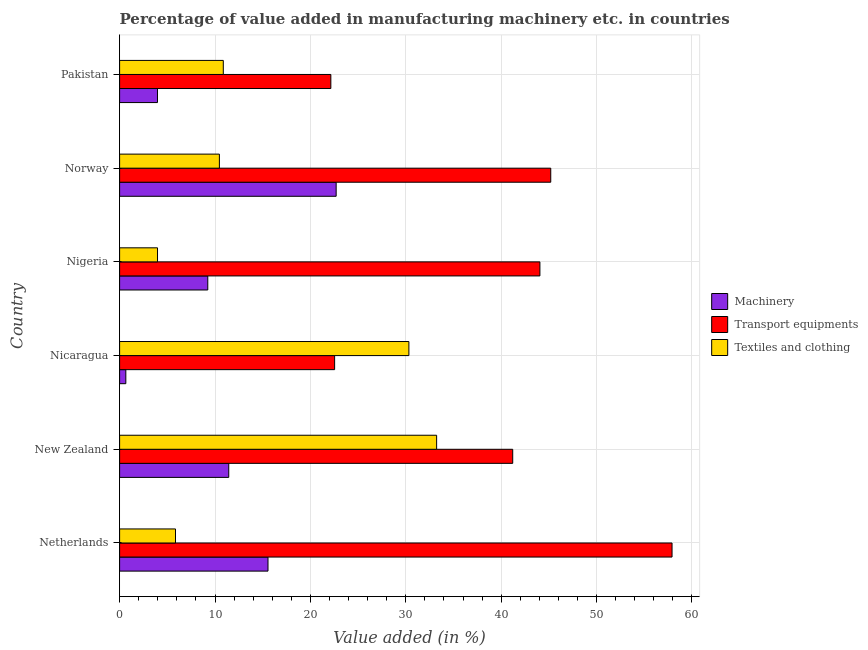How many different coloured bars are there?
Your response must be concise. 3. Are the number of bars per tick equal to the number of legend labels?
Offer a terse response. Yes. How many bars are there on the 3rd tick from the top?
Make the answer very short. 3. What is the label of the 3rd group of bars from the top?
Your answer should be very brief. Nigeria. In how many cases, is the number of bars for a given country not equal to the number of legend labels?
Offer a terse response. 0. What is the value added in manufacturing textile and clothing in Norway?
Keep it short and to the point. 10.46. Across all countries, what is the maximum value added in manufacturing machinery?
Your answer should be very brief. 22.7. Across all countries, what is the minimum value added in manufacturing transport equipments?
Your response must be concise. 22.14. In which country was the value added in manufacturing machinery minimum?
Provide a short and direct response. Nicaragua. What is the total value added in manufacturing textile and clothing in the graph?
Your response must be concise. 94.72. What is the difference between the value added in manufacturing machinery in Nigeria and that in Norway?
Provide a short and direct response. -13.46. What is the difference between the value added in manufacturing transport equipments in Norway and the value added in manufacturing machinery in Nicaragua?
Your answer should be very brief. 44.54. What is the average value added in manufacturing textile and clothing per country?
Keep it short and to the point. 15.79. What is the difference between the value added in manufacturing textile and clothing and value added in manufacturing transport equipments in Nigeria?
Ensure brevity in your answer.  -40.09. What is the ratio of the value added in manufacturing machinery in New Zealand to that in Nigeria?
Ensure brevity in your answer.  1.24. Is the value added in manufacturing machinery in Norway less than that in Pakistan?
Offer a very short reply. No. What is the difference between the highest and the second highest value added in manufacturing transport equipments?
Make the answer very short. 12.71. What is the difference between the highest and the lowest value added in manufacturing transport equipments?
Your response must be concise. 35.77. In how many countries, is the value added in manufacturing transport equipments greater than the average value added in manufacturing transport equipments taken over all countries?
Offer a terse response. 4. What does the 1st bar from the top in Nigeria represents?
Keep it short and to the point. Textiles and clothing. What does the 2nd bar from the bottom in Nigeria represents?
Ensure brevity in your answer.  Transport equipments. How many bars are there?
Offer a terse response. 18. How many countries are there in the graph?
Provide a succinct answer. 6. Are the values on the major ticks of X-axis written in scientific E-notation?
Offer a very short reply. No. Does the graph contain any zero values?
Your answer should be compact. No. Does the graph contain grids?
Your answer should be very brief. Yes. How many legend labels are there?
Your answer should be very brief. 3. How are the legend labels stacked?
Your answer should be compact. Vertical. What is the title of the graph?
Offer a very short reply. Percentage of value added in manufacturing machinery etc. in countries. Does "Taxes on income" appear as one of the legend labels in the graph?
Your response must be concise. No. What is the label or title of the X-axis?
Your response must be concise. Value added (in %). What is the Value added (in %) in Machinery in Netherlands?
Provide a succinct answer. 15.56. What is the Value added (in %) of Transport equipments in Netherlands?
Provide a succinct answer. 57.91. What is the Value added (in %) of Textiles and clothing in Netherlands?
Provide a succinct answer. 5.86. What is the Value added (in %) in Machinery in New Zealand?
Give a very brief answer. 11.44. What is the Value added (in %) of Transport equipments in New Zealand?
Offer a terse response. 41.21. What is the Value added (in %) in Textiles and clothing in New Zealand?
Give a very brief answer. 33.23. What is the Value added (in %) in Machinery in Nicaragua?
Ensure brevity in your answer.  0.65. What is the Value added (in %) of Transport equipments in Nicaragua?
Provide a short and direct response. 22.54. What is the Value added (in %) of Textiles and clothing in Nicaragua?
Provide a succinct answer. 30.33. What is the Value added (in %) in Machinery in Nigeria?
Offer a terse response. 9.24. What is the Value added (in %) in Transport equipments in Nigeria?
Your answer should be very brief. 44.06. What is the Value added (in %) of Textiles and clothing in Nigeria?
Provide a succinct answer. 3.97. What is the Value added (in %) in Machinery in Norway?
Keep it short and to the point. 22.7. What is the Value added (in %) of Transport equipments in Norway?
Offer a terse response. 45.2. What is the Value added (in %) of Textiles and clothing in Norway?
Offer a terse response. 10.46. What is the Value added (in %) in Machinery in Pakistan?
Give a very brief answer. 3.97. What is the Value added (in %) in Transport equipments in Pakistan?
Your response must be concise. 22.14. What is the Value added (in %) of Textiles and clothing in Pakistan?
Your answer should be very brief. 10.87. Across all countries, what is the maximum Value added (in %) of Machinery?
Provide a short and direct response. 22.7. Across all countries, what is the maximum Value added (in %) of Transport equipments?
Your answer should be very brief. 57.91. Across all countries, what is the maximum Value added (in %) of Textiles and clothing?
Make the answer very short. 33.23. Across all countries, what is the minimum Value added (in %) of Machinery?
Offer a terse response. 0.65. Across all countries, what is the minimum Value added (in %) of Transport equipments?
Provide a short and direct response. 22.14. Across all countries, what is the minimum Value added (in %) of Textiles and clothing?
Provide a short and direct response. 3.97. What is the total Value added (in %) in Machinery in the graph?
Ensure brevity in your answer.  63.57. What is the total Value added (in %) of Transport equipments in the graph?
Make the answer very short. 233.06. What is the total Value added (in %) in Textiles and clothing in the graph?
Your answer should be very brief. 94.72. What is the difference between the Value added (in %) of Machinery in Netherlands and that in New Zealand?
Offer a very short reply. 4.11. What is the difference between the Value added (in %) in Transport equipments in Netherlands and that in New Zealand?
Offer a very short reply. 16.7. What is the difference between the Value added (in %) of Textiles and clothing in Netherlands and that in New Zealand?
Provide a short and direct response. -27.37. What is the difference between the Value added (in %) of Machinery in Netherlands and that in Nicaragua?
Offer a terse response. 14.9. What is the difference between the Value added (in %) in Transport equipments in Netherlands and that in Nicaragua?
Your answer should be very brief. 35.37. What is the difference between the Value added (in %) of Textiles and clothing in Netherlands and that in Nicaragua?
Provide a short and direct response. -24.47. What is the difference between the Value added (in %) in Machinery in Netherlands and that in Nigeria?
Provide a succinct answer. 6.31. What is the difference between the Value added (in %) of Transport equipments in Netherlands and that in Nigeria?
Provide a succinct answer. 13.85. What is the difference between the Value added (in %) of Textiles and clothing in Netherlands and that in Nigeria?
Your answer should be compact. 1.88. What is the difference between the Value added (in %) of Machinery in Netherlands and that in Norway?
Your answer should be very brief. -7.14. What is the difference between the Value added (in %) in Transport equipments in Netherlands and that in Norway?
Ensure brevity in your answer.  12.71. What is the difference between the Value added (in %) of Textiles and clothing in Netherlands and that in Norway?
Your response must be concise. -4.6. What is the difference between the Value added (in %) in Machinery in Netherlands and that in Pakistan?
Make the answer very short. 11.59. What is the difference between the Value added (in %) in Transport equipments in Netherlands and that in Pakistan?
Provide a short and direct response. 35.77. What is the difference between the Value added (in %) in Textiles and clothing in Netherlands and that in Pakistan?
Make the answer very short. -5.01. What is the difference between the Value added (in %) of Machinery in New Zealand and that in Nicaragua?
Your answer should be very brief. 10.79. What is the difference between the Value added (in %) of Transport equipments in New Zealand and that in Nicaragua?
Your response must be concise. 18.67. What is the difference between the Value added (in %) in Textiles and clothing in New Zealand and that in Nicaragua?
Offer a very short reply. 2.91. What is the difference between the Value added (in %) of Machinery in New Zealand and that in Nigeria?
Your answer should be very brief. 2.2. What is the difference between the Value added (in %) of Transport equipments in New Zealand and that in Nigeria?
Your answer should be compact. -2.85. What is the difference between the Value added (in %) in Textiles and clothing in New Zealand and that in Nigeria?
Provide a succinct answer. 29.26. What is the difference between the Value added (in %) in Machinery in New Zealand and that in Norway?
Your response must be concise. -11.26. What is the difference between the Value added (in %) in Transport equipments in New Zealand and that in Norway?
Your response must be concise. -3.99. What is the difference between the Value added (in %) of Textiles and clothing in New Zealand and that in Norway?
Your answer should be compact. 22.77. What is the difference between the Value added (in %) in Machinery in New Zealand and that in Pakistan?
Your response must be concise. 7.47. What is the difference between the Value added (in %) in Transport equipments in New Zealand and that in Pakistan?
Your answer should be compact. 19.06. What is the difference between the Value added (in %) in Textiles and clothing in New Zealand and that in Pakistan?
Ensure brevity in your answer.  22.36. What is the difference between the Value added (in %) in Machinery in Nicaragua and that in Nigeria?
Offer a terse response. -8.59. What is the difference between the Value added (in %) in Transport equipments in Nicaragua and that in Nigeria?
Your answer should be compact. -21.52. What is the difference between the Value added (in %) in Textiles and clothing in Nicaragua and that in Nigeria?
Offer a very short reply. 26.35. What is the difference between the Value added (in %) of Machinery in Nicaragua and that in Norway?
Keep it short and to the point. -22.05. What is the difference between the Value added (in %) of Transport equipments in Nicaragua and that in Norway?
Offer a terse response. -22.66. What is the difference between the Value added (in %) in Textiles and clothing in Nicaragua and that in Norway?
Provide a short and direct response. 19.87. What is the difference between the Value added (in %) of Machinery in Nicaragua and that in Pakistan?
Provide a short and direct response. -3.32. What is the difference between the Value added (in %) in Transport equipments in Nicaragua and that in Pakistan?
Your response must be concise. 0.4. What is the difference between the Value added (in %) of Textiles and clothing in Nicaragua and that in Pakistan?
Make the answer very short. 19.46. What is the difference between the Value added (in %) in Machinery in Nigeria and that in Norway?
Keep it short and to the point. -13.46. What is the difference between the Value added (in %) in Transport equipments in Nigeria and that in Norway?
Give a very brief answer. -1.14. What is the difference between the Value added (in %) in Textiles and clothing in Nigeria and that in Norway?
Your answer should be compact. -6.49. What is the difference between the Value added (in %) of Machinery in Nigeria and that in Pakistan?
Your response must be concise. 5.27. What is the difference between the Value added (in %) in Transport equipments in Nigeria and that in Pakistan?
Your answer should be very brief. 21.92. What is the difference between the Value added (in %) of Textiles and clothing in Nigeria and that in Pakistan?
Your answer should be compact. -6.89. What is the difference between the Value added (in %) in Machinery in Norway and that in Pakistan?
Your response must be concise. 18.73. What is the difference between the Value added (in %) in Transport equipments in Norway and that in Pakistan?
Your answer should be very brief. 23.05. What is the difference between the Value added (in %) of Textiles and clothing in Norway and that in Pakistan?
Provide a short and direct response. -0.41. What is the difference between the Value added (in %) in Machinery in Netherlands and the Value added (in %) in Transport equipments in New Zealand?
Provide a succinct answer. -25.65. What is the difference between the Value added (in %) in Machinery in Netherlands and the Value added (in %) in Textiles and clothing in New Zealand?
Offer a terse response. -17.68. What is the difference between the Value added (in %) in Transport equipments in Netherlands and the Value added (in %) in Textiles and clothing in New Zealand?
Provide a short and direct response. 24.68. What is the difference between the Value added (in %) in Machinery in Netherlands and the Value added (in %) in Transport equipments in Nicaragua?
Provide a succinct answer. -6.98. What is the difference between the Value added (in %) of Machinery in Netherlands and the Value added (in %) of Textiles and clothing in Nicaragua?
Ensure brevity in your answer.  -14.77. What is the difference between the Value added (in %) in Transport equipments in Netherlands and the Value added (in %) in Textiles and clothing in Nicaragua?
Your answer should be compact. 27.59. What is the difference between the Value added (in %) of Machinery in Netherlands and the Value added (in %) of Transport equipments in Nigeria?
Your response must be concise. -28.5. What is the difference between the Value added (in %) in Machinery in Netherlands and the Value added (in %) in Textiles and clothing in Nigeria?
Your response must be concise. 11.58. What is the difference between the Value added (in %) of Transport equipments in Netherlands and the Value added (in %) of Textiles and clothing in Nigeria?
Keep it short and to the point. 53.94. What is the difference between the Value added (in %) in Machinery in Netherlands and the Value added (in %) in Transport equipments in Norway?
Offer a very short reply. -29.64. What is the difference between the Value added (in %) in Machinery in Netherlands and the Value added (in %) in Textiles and clothing in Norway?
Your response must be concise. 5.1. What is the difference between the Value added (in %) in Transport equipments in Netherlands and the Value added (in %) in Textiles and clothing in Norway?
Give a very brief answer. 47.45. What is the difference between the Value added (in %) of Machinery in Netherlands and the Value added (in %) of Transport equipments in Pakistan?
Provide a short and direct response. -6.59. What is the difference between the Value added (in %) in Machinery in Netherlands and the Value added (in %) in Textiles and clothing in Pakistan?
Provide a short and direct response. 4.69. What is the difference between the Value added (in %) of Transport equipments in Netherlands and the Value added (in %) of Textiles and clothing in Pakistan?
Your answer should be very brief. 47.04. What is the difference between the Value added (in %) in Machinery in New Zealand and the Value added (in %) in Transport equipments in Nicaragua?
Your answer should be very brief. -11.1. What is the difference between the Value added (in %) of Machinery in New Zealand and the Value added (in %) of Textiles and clothing in Nicaragua?
Ensure brevity in your answer.  -18.88. What is the difference between the Value added (in %) in Transport equipments in New Zealand and the Value added (in %) in Textiles and clothing in Nicaragua?
Offer a very short reply. 10.88. What is the difference between the Value added (in %) in Machinery in New Zealand and the Value added (in %) in Transport equipments in Nigeria?
Give a very brief answer. -32.62. What is the difference between the Value added (in %) in Machinery in New Zealand and the Value added (in %) in Textiles and clothing in Nigeria?
Make the answer very short. 7.47. What is the difference between the Value added (in %) of Transport equipments in New Zealand and the Value added (in %) of Textiles and clothing in Nigeria?
Provide a short and direct response. 37.23. What is the difference between the Value added (in %) in Machinery in New Zealand and the Value added (in %) in Transport equipments in Norway?
Offer a very short reply. -33.75. What is the difference between the Value added (in %) in Machinery in New Zealand and the Value added (in %) in Textiles and clothing in Norway?
Give a very brief answer. 0.98. What is the difference between the Value added (in %) in Transport equipments in New Zealand and the Value added (in %) in Textiles and clothing in Norway?
Offer a terse response. 30.75. What is the difference between the Value added (in %) in Machinery in New Zealand and the Value added (in %) in Transport equipments in Pakistan?
Ensure brevity in your answer.  -10.7. What is the difference between the Value added (in %) in Machinery in New Zealand and the Value added (in %) in Textiles and clothing in Pakistan?
Provide a short and direct response. 0.57. What is the difference between the Value added (in %) of Transport equipments in New Zealand and the Value added (in %) of Textiles and clothing in Pakistan?
Offer a very short reply. 30.34. What is the difference between the Value added (in %) of Machinery in Nicaragua and the Value added (in %) of Transport equipments in Nigeria?
Offer a terse response. -43.41. What is the difference between the Value added (in %) of Machinery in Nicaragua and the Value added (in %) of Textiles and clothing in Nigeria?
Make the answer very short. -3.32. What is the difference between the Value added (in %) in Transport equipments in Nicaragua and the Value added (in %) in Textiles and clothing in Nigeria?
Your answer should be compact. 18.56. What is the difference between the Value added (in %) in Machinery in Nicaragua and the Value added (in %) in Transport equipments in Norway?
Provide a succinct answer. -44.54. What is the difference between the Value added (in %) in Machinery in Nicaragua and the Value added (in %) in Textiles and clothing in Norway?
Make the answer very short. -9.81. What is the difference between the Value added (in %) in Transport equipments in Nicaragua and the Value added (in %) in Textiles and clothing in Norway?
Offer a very short reply. 12.08. What is the difference between the Value added (in %) in Machinery in Nicaragua and the Value added (in %) in Transport equipments in Pakistan?
Provide a succinct answer. -21.49. What is the difference between the Value added (in %) of Machinery in Nicaragua and the Value added (in %) of Textiles and clothing in Pakistan?
Provide a short and direct response. -10.22. What is the difference between the Value added (in %) in Transport equipments in Nicaragua and the Value added (in %) in Textiles and clothing in Pakistan?
Offer a very short reply. 11.67. What is the difference between the Value added (in %) of Machinery in Nigeria and the Value added (in %) of Transport equipments in Norway?
Make the answer very short. -35.95. What is the difference between the Value added (in %) of Machinery in Nigeria and the Value added (in %) of Textiles and clothing in Norway?
Ensure brevity in your answer.  -1.22. What is the difference between the Value added (in %) in Transport equipments in Nigeria and the Value added (in %) in Textiles and clothing in Norway?
Your response must be concise. 33.6. What is the difference between the Value added (in %) in Machinery in Nigeria and the Value added (in %) in Transport equipments in Pakistan?
Your answer should be very brief. -12.9. What is the difference between the Value added (in %) in Machinery in Nigeria and the Value added (in %) in Textiles and clothing in Pakistan?
Make the answer very short. -1.63. What is the difference between the Value added (in %) of Transport equipments in Nigeria and the Value added (in %) of Textiles and clothing in Pakistan?
Your answer should be very brief. 33.19. What is the difference between the Value added (in %) in Machinery in Norway and the Value added (in %) in Transport equipments in Pakistan?
Offer a terse response. 0.56. What is the difference between the Value added (in %) in Machinery in Norway and the Value added (in %) in Textiles and clothing in Pakistan?
Ensure brevity in your answer.  11.83. What is the difference between the Value added (in %) of Transport equipments in Norway and the Value added (in %) of Textiles and clothing in Pakistan?
Provide a succinct answer. 34.33. What is the average Value added (in %) in Machinery per country?
Ensure brevity in your answer.  10.59. What is the average Value added (in %) of Transport equipments per country?
Ensure brevity in your answer.  38.84. What is the average Value added (in %) of Textiles and clothing per country?
Ensure brevity in your answer.  15.79. What is the difference between the Value added (in %) of Machinery and Value added (in %) of Transport equipments in Netherlands?
Keep it short and to the point. -42.35. What is the difference between the Value added (in %) in Machinery and Value added (in %) in Textiles and clothing in Netherlands?
Your response must be concise. 9.7. What is the difference between the Value added (in %) in Transport equipments and Value added (in %) in Textiles and clothing in Netherlands?
Ensure brevity in your answer.  52.05. What is the difference between the Value added (in %) in Machinery and Value added (in %) in Transport equipments in New Zealand?
Make the answer very short. -29.77. What is the difference between the Value added (in %) of Machinery and Value added (in %) of Textiles and clothing in New Zealand?
Offer a very short reply. -21.79. What is the difference between the Value added (in %) of Transport equipments and Value added (in %) of Textiles and clothing in New Zealand?
Your response must be concise. 7.98. What is the difference between the Value added (in %) in Machinery and Value added (in %) in Transport equipments in Nicaragua?
Offer a terse response. -21.89. What is the difference between the Value added (in %) of Machinery and Value added (in %) of Textiles and clothing in Nicaragua?
Offer a terse response. -29.67. What is the difference between the Value added (in %) of Transport equipments and Value added (in %) of Textiles and clothing in Nicaragua?
Provide a succinct answer. -7.79. What is the difference between the Value added (in %) in Machinery and Value added (in %) in Transport equipments in Nigeria?
Keep it short and to the point. -34.82. What is the difference between the Value added (in %) in Machinery and Value added (in %) in Textiles and clothing in Nigeria?
Give a very brief answer. 5.27. What is the difference between the Value added (in %) of Transport equipments and Value added (in %) of Textiles and clothing in Nigeria?
Keep it short and to the point. 40.09. What is the difference between the Value added (in %) in Machinery and Value added (in %) in Transport equipments in Norway?
Your response must be concise. -22.5. What is the difference between the Value added (in %) of Machinery and Value added (in %) of Textiles and clothing in Norway?
Provide a succinct answer. 12.24. What is the difference between the Value added (in %) of Transport equipments and Value added (in %) of Textiles and clothing in Norway?
Your answer should be very brief. 34.74. What is the difference between the Value added (in %) in Machinery and Value added (in %) in Transport equipments in Pakistan?
Your response must be concise. -18.17. What is the difference between the Value added (in %) of Machinery and Value added (in %) of Textiles and clothing in Pakistan?
Offer a terse response. -6.9. What is the difference between the Value added (in %) in Transport equipments and Value added (in %) in Textiles and clothing in Pakistan?
Offer a very short reply. 11.27. What is the ratio of the Value added (in %) in Machinery in Netherlands to that in New Zealand?
Make the answer very short. 1.36. What is the ratio of the Value added (in %) of Transport equipments in Netherlands to that in New Zealand?
Provide a short and direct response. 1.41. What is the ratio of the Value added (in %) of Textiles and clothing in Netherlands to that in New Zealand?
Your answer should be compact. 0.18. What is the ratio of the Value added (in %) in Machinery in Netherlands to that in Nicaragua?
Your answer should be very brief. 23.83. What is the ratio of the Value added (in %) in Transport equipments in Netherlands to that in Nicaragua?
Provide a short and direct response. 2.57. What is the ratio of the Value added (in %) in Textiles and clothing in Netherlands to that in Nicaragua?
Keep it short and to the point. 0.19. What is the ratio of the Value added (in %) of Machinery in Netherlands to that in Nigeria?
Offer a terse response. 1.68. What is the ratio of the Value added (in %) in Transport equipments in Netherlands to that in Nigeria?
Your answer should be very brief. 1.31. What is the ratio of the Value added (in %) of Textiles and clothing in Netherlands to that in Nigeria?
Provide a short and direct response. 1.47. What is the ratio of the Value added (in %) in Machinery in Netherlands to that in Norway?
Provide a short and direct response. 0.69. What is the ratio of the Value added (in %) in Transport equipments in Netherlands to that in Norway?
Your answer should be very brief. 1.28. What is the ratio of the Value added (in %) in Textiles and clothing in Netherlands to that in Norway?
Keep it short and to the point. 0.56. What is the ratio of the Value added (in %) of Machinery in Netherlands to that in Pakistan?
Keep it short and to the point. 3.92. What is the ratio of the Value added (in %) of Transport equipments in Netherlands to that in Pakistan?
Your answer should be compact. 2.62. What is the ratio of the Value added (in %) of Textiles and clothing in Netherlands to that in Pakistan?
Give a very brief answer. 0.54. What is the ratio of the Value added (in %) of Machinery in New Zealand to that in Nicaragua?
Your response must be concise. 17.53. What is the ratio of the Value added (in %) in Transport equipments in New Zealand to that in Nicaragua?
Offer a very short reply. 1.83. What is the ratio of the Value added (in %) of Textiles and clothing in New Zealand to that in Nicaragua?
Provide a short and direct response. 1.1. What is the ratio of the Value added (in %) of Machinery in New Zealand to that in Nigeria?
Offer a terse response. 1.24. What is the ratio of the Value added (in %) in Transport equipments in New Zealand to that in Nigeria?
Your answer should be compact. 0.94. What is the ratio of the Value added (in %) in Textiles and clothing in New Zealand to that in Nigeria?
Provide a succinct answer. 8.36. What is the ratio of the Value added (in %) of Machinery in New Zealand to that in Norway?
Ensure brevity in your answer.  0.5. What is the ratio of the Value added (in %) in Transport equipments in New Zealand to that in Norway?
Give a very brief answer. 0.91. What is the ratio of the Value added (in %) in Textiles and clothing in New Zealand to that in Norway?
Provide a short and direct response. 3.18. What is the ratio of the Value added (in %) in Machinery in New Zealand to that in Pakistan?
Make the answer very short. 2.88. What is the ratio of the Value added (in %) of Transport equipments in New Zealand to that in Pakistan?
Provide a short and direct response. 1.86. What is the ratio of the Value added (in %) in Textiles and clothing in New Zealand to that in Pakistan?
Keep it short and to the point. 3.06. What is the ratio of the Value added (in %) of Machinery in Nicaragua to that in Nigeria?
Offer a terse response. 0.07. What is the ratio of the Value added (in %) of Transport equipments in Nicaragua to that in Nigeria?
Ensure brevity in your answer.  0.51. What is the ratio of the Value added (in %) of Textiles and clothing in Nicaragua to that in Nigeria?
Ensure brevity in your answer.  7.63. What is the ratio of the Value added (in %) of Machinery in Nicaragua to that in Norway?
Your response must be concise. 0.03. What is the ratio of the Value added (in %) of Transport equipments in Nicaragua to that in Norway?
Your answer should be very brief. 0.5. What is the ratio of the Value added (in %) in Textiles and clothing in Nicaragua to that in Norway?
Ensure brevity in your answer.  2.9. What is the ratio of the Value added (in %) of Machinery in Nicaragua to that in Pakistan?
Ensure brevity in your answer.  0.16. What is the ratio of the Value added (in %) in Transport equipments in Nicaragua to that in Pakistan?
Offer a terse response. 1.02. What is the ratio of the Value added (in %) in Textiles and clothing in Nicaragua to that in Pakistan?
Make the answer very short. 2.79. What is the ratio of the Value added (in %) of Machinery in Nigeria to that in Norway?
Give a very brief answer. 0.41. What is the ratio of the Value added (in %) of Transport equipments in Nigeria to that in Norway?
Your response must be concise. 0.97. What is the ratio of the Value added (in %) of Textiles and clothing in Nigeria to that in Norway?
Provide a short and direct response. 0.38. What is the ratio of the Value added (in %) of Machinery in Nigeria to that in Pakistan?
Make the answer very short. 2.33. What is the ratio of the Value added (in %) in Transport equipments in Nigeria to that in Pakistan?
Offer a terse response. 1.99. What is the ratio of the Value added (in %) in Textiles and clothing in Nigeria to that in Pakistan?
Provide a short and direct response. 0.37. What is the ratio of the Value added (in %) of Machinery in Norway to that in Pakistan?
Provide a short and direct response. 5.72. What is the ratio of the Value added (in %) of Transport equipments in Norway to that in Pakistan?
Offer a very short reply. 2.04. What is the ratio of the Value added (in %) of Textiles and clothing in Norway to that in Pakistan?
Your response must be concise. 0.96. What is the difference between the highest and the second highest Value added (in %) in Machinery?
Provide a short and direct response. 7.14. What is the difference between the highest and the second highest Value added (in %) in Transport equipments?
Provide a succinct answer. 12.71. What is the difference between the highest and the second highest Value added (in %) in Textiles and clothing?
Offer a terse response. 2.91. What is the difference between the highest and the lowest Value added (in %) in Machinery?
Give a very brief answer. 22.05. What is the difference between the highest and the lowest Value added (in %) in Transport equipments?
Your answer should be very brief. 35.77. What is the difference between the highest and the lowest Value added (in %) in Textiles and clothing?
Provide a short and direct response. 29.26. 